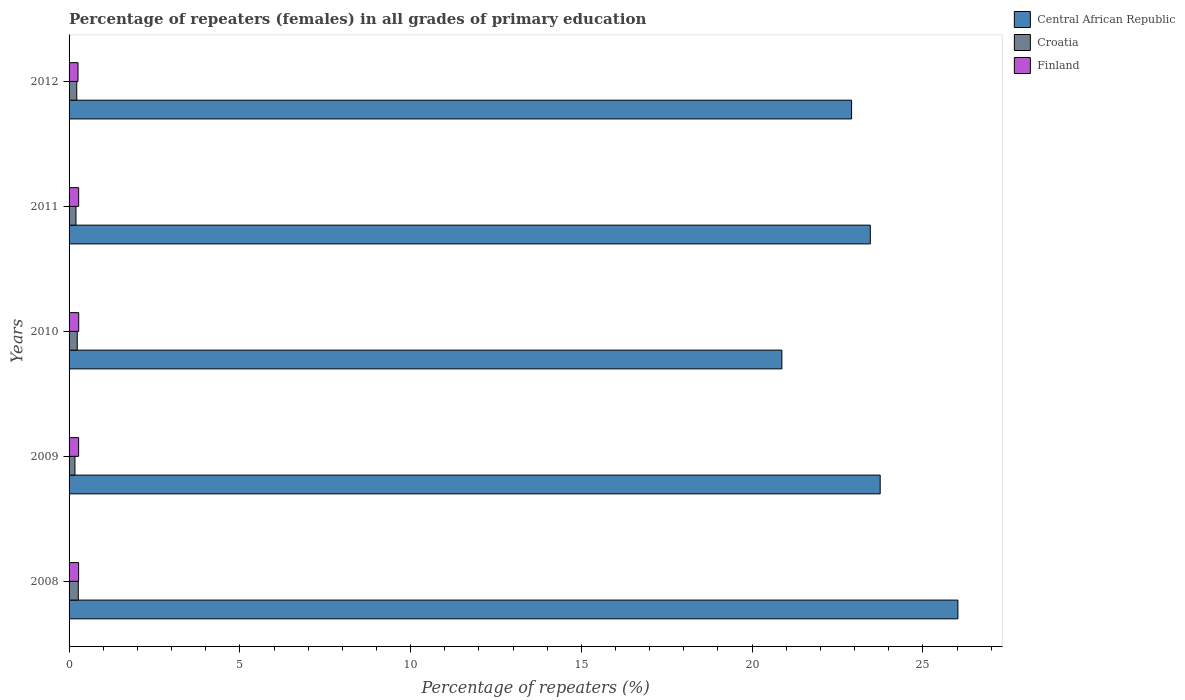How many groups of bars are there?
Offer a terse response. 5. Are the number of bars per tick equal to the number of legend labels?
Provide a short and direct response. Yes. How many bars are there on the 2nd tick from the top?
Keep it short and to the point. 3. In how many cases, is the number of bars for a given year not equal to the number of legend labels?
Provide a short and direct response. 0. What is the percentage of repeaters (females) in Croatia in 2012?
Offer a very short reply. 0.22. Across all years, what is the maximum percentage of repeaters (females) in Finland?
Keep it short and to the point. 0.28. Across all years, what is the minimum percentage of repeaters (females) in Central African Republic?
Make the answer very short. 20.87. In which year was the percentage of repeaters (females) in Central African Republic maximum?
Ensure brevity in your answer.  2008. In which year was the percentage of repeaters (females) in Croatia minimum?
Ensure brevity in your answer.  2009. What is the total percentage of repeaters (females) in Croatia in the graph?
Your answer should be compact. 1.11. What is the difference between the percentage of repeaters (females) in Finland in 2009 and that in 2010?
Ensure brevity in your answer.  -0. What is the difference between the percentage of repeaters (females) in Finland in 2009 and the percentage of repeaters (females) in Central African Republic in 2008?
Your response must be concise. -25.74. What is the average percentage of repeaters (females) in Central African Republic per year?
Make the answer very short. 23.4. In the year 2008, what is the difference between the percentage of repeaters (females) in Central African Republic and percentage of repeaters (females) in Croatia?
Make the answer very short. 25.75. What is the ratio of the percentage of repeaters (females) in Croatia in 2009 to that in 2011?
Make the answer very short. 0.85. Is the difference between the percentage of repeaters (females) in Central African Republic in 2009 and 2011 greater than the difference between the percentage of repeaters (females) in Croatia in 2009 and 2011?
Provide a succinct answer. Yes. What is the difference between the highest and the second highest percentage of repeaters (females) in Central African Republic?
Ensure brevity in your answer.  2.28. What is the difference between the highest and the lowest percentage of repeaters (females) in Croatia?
Provide a succinct answer. 0.1. In how many years, is the percentage of repeaters (females) in Croatia greater than the average percentage of repeaters (females) in Croatia taken over all years?
Keep it short and to the point. 3. What does the 2nd bar from the top in 2012 represents?
Keep it short and to the point. Croatia. What does the 2nd bar from the bottom in 2012 represents?
Your response must be concise. Croatia. Is it the case that in every year, the sum of the percentage of repeaters (females) in Finland and percentage of repeaters (females) in Croatia is greater than the percentage of repeaters (females) in Central African Republic?
Offer a terse response. No. Are all the bars in the graph horizontal?
Offer a terse response. Yes. How many years are there in the graph?
Ensure brevity in your answer.  5. What is the difference between two consecutive major ticks on the X-axis?
Keep it short and to the point. 5. Does the graph contain any zero values?
Offer a very short reply. No. Does the graph contain grids?
Your answer should be compact. No. What is the title of the graph?
Give a very brief answer. Percentage of repeaters (females) in all grades of primary education. Does "Mauritius" appear as one of the legend labels in the graph?
Offer a very short reply. No. What is the label or title of the X-axis?
Give a very brief answer. Percentage of repeaters (%). What is the label or title of the Y-axis?
Your answer should be very brief. Years. What is the Percentage of repeaters (%) of Central African Republic in 2008?
Provide a succinct answer. 26.02. What is the Percentage of repeaters (%) of Croatia in 2008?
Your response must be concise. 0.27. What is the Percentage of repeaters (%) in Finland in 2008?
Ensure brevity in your answer.  0.28. What is the Percentage of repeaters (%) in Central African Republic in 2009?
Your answer should be compact. 23.75. What is the Percentage of repeaters (%) of Croatia in 2009?
Keep it short and to the point. 0.17. What is the Percentage of repeaters (%) in Finland in 2009?
Your response must be concise. 0.28. What is the Percentage of repeaters (%) of Central African Republic in 2010?
Your answer should be very brief. 20.87. What is the Percentage of repeaters (%) in Croatia in 2010?
Offer a terse response. 0.24. What is the Percentage of repeaters (%) of Finland in 2010?
Your answer should be very brief. 0.28. What is the Percentage of repeaters (%) in Central African Republic in 2011?
Give a very brief answer. 23.46. What is the Percentage of repeaters (%) of Croatia in 2011?
Make the answer very short. 0.2. What is the Percentage of repeaters (%) of Finland in 2011?
Give a very brief answer. 0.28. What is the Percentage of repeaters (%) of Central African Republic in 2012?
Provide a short and direct response. 22.91. What is the Percentage of repeaters (%) of Croatia in 2012?
Your answer should be compact. 0.22. What is the Percentage of repeaters (%) of Finland in 2012?
Offer a very short reply. 0.26. Across all years, what is the maximum Percentage of repeaters (%) in Central African Republic?
Your response must be concise. 26.02. Across all years, what is the maximum Percentage of repeaters (%) of Croatia?
Give a very brief answer. 0.27. Across all years, what is the maximum Percentage of repeaters (%) in Finland?
Your response must be concise. 0.28. Across all years, what is the minimum Percentage of repeaters (%) of Central African Republic?
Provide a succinct answer. 20.87. Across all years, what is the minimum Percentage of repeaters (%) of Croatia?
Your answer should be very brief. 0.17. Across all years, what is the minimum Percentage of repeaters (%) in Finland?
Offer a very short reply. 0.26. What is the total Percentage of repeaters (%) in Central African Republic in the graph?
Your answer should be very brief. 117.02. What is the total Percentage of repeaters (%) of Croatia in the graph?
Your answer should be very brief. 1.11. What is the total Percentage of repeaters (%) of Finland in the graph?
Your answer should be very brief. 1.38. What is the difference between the Percentage of repeaters (%) of Central African Republic in 2008 and that in 2009?
Your response must be concise. 2.28. What is the difference between the Percentage of repeaters (%) in Croatia in 2008 and that in 2009?
Make the answer very short. 0.1. What is the difference between the Percentage of repeaters (%) of Finland in 2008 and that in 2009?
Your response must be concise. -0. What is the difference between the Percentage of repeaters (%) of Central African Republic in 2008 and that in 2010?
Offer a very short reply. 5.15. What is the difference between the Percentage of repeaters (%) of Croatia in 2008 and that in 2010?
Ensure brevity in your answer.  0.03. What is the difference between the Percentage of repeaters (%) of Finland in 2008 and that in 2010?
Give a very brief answer. -0. What is the difference between the Percentage of repeaters (%) in Central African Republic in 2008 and that in 2011?
Your answer should be compact. 2.56. What is the difference between the Percentage of repeaters (%) of Croatia in 2008 and that in 2011?
Offer a terse response. 0.07. What is the difference between the Percentage of repeaters (%) in Finland in 2008 and that in 2011?
Your answer should be compact. -0. What is the difference between the Percentage of repeaters (%) in Central African Republic in 2008 and that in 2012?
Give a very brief answer. 3.11. What is the difference between the Percentage of repeaters (%) of Croatia in 2008 and that in 2012?
Give a very brief answer. 0.05. What is the difference between the Percentage of repeaters (%) of Finland in 2008 and that in 2012?
Your response must be concise. 0.02. What is the difference between the Percentage of repeaters (%) of Central African Republic in 2009 and that in 2010?
Give a very brief answer. 2.88. What is the difference between the Percentage of repeaters (%) in Croatia in 2009 and that in 2010?
Your response must be concise. -0.07. What is the difference between the Percentage of repeaters (%) in Finland in 2009 and that in 2010?
Your response must be concise. -0. What is the difference between the Percentage of repeaters (%) in Central African Republic in 2009 and that in 2011?
Provide a short and direct response. 0.29. What is the difference between the Percentage of repeaters (%) of Croatia in 2009 and that in 2011?
Your answer should be very brief. -0.03. What is the difference between the Percentage of repeaters (%) of Finland in 2009 and that in 2011?
Your answer should be very brief. -0. What is the difference between the Percentage of repeaters (%) in Central African Republic in 2009 and that in 2012?
Ensure brevity in your answer.  0.84. What is the difference between the Percentage of repeaters (%) in Croatia in 2009 and that in 2012?
Give a very brief answer. -0.05. What is the difference between the Percentage of repeaters (%) in Finland in 2009 and that in 2012?
Give a very brief answer. 0.02. What is the difference between the Percentage of repeaters (%) of Central African Republic in 2010 and that in 2011?
Provide a succinct answer. -2.59. What is the difference between the Percentage of repeaters (%) of Croatia in 2010 and that in 2011?
Offer a very short reply. 0.04. What is the difference between the Percentage of repeaters (%) of Finland in 2010 and that in 2011?
Ensure brevity in your answer.  0. What is the difference between the Percentage of repeaters (%) of Central African Republic in 2010 and that in 2012?
Provide a short and direct response. -2.04. What is the difference between the Percentage of repeaters (%) of Croatia in 2010 and that in 2012?
Make the answer very short. 0.01. What is the difference between the Percentage of repeaters (%) of Finland in 2010 and that in 2012?
Provide a succinct answer. 0.02. What is the difference between the Percentage of repeaters (%) in Central African Republic in 2011 and that in 2012?
Make the answer very short. 0.55. What is the difference between the Percentage of repeaters (%) of Croatia in 2011 and that in 2012?
Offer a terse response. -0.02. What is the difference between the Percentage of repeaters (%) of Finland in 2011 and that in 2012?
Your answer should be very brief. 0.02. What is the difference between the Percentage of repeaters (%) of Central African Republic in 2008 and the Percentage of repeaters (%) of Croatia in 2009?
Offer a terse response. 25.85. What is the difference between the Percentage of repeaters (%) of Central African Republic in 2008 and the Percentage of repeaters (%) of Finland in 2009?
Your answer should be compact. 25.74. What is the difference between the Percentage of repeaters (%) of Croatia in 2008 and the Percentage of repeaters (%) of Finland in 2009?
Your response must be concise. -0.01. What is the difference between the Percentage of repeaters (%) in Central African Republic in 2008 and the Percentage of repeaters (%) in Croatia in 2010?
Ensure brevity in your answer.  25.79. What is the difference between the Percentage of repeaters (%) in Central African Republic in 2008 and the Percentage of repeaters (%) in Finland in 2010?
Your answer should be compact. 25.74. What is the difference between the Percentage of repeaters (%) of Croatia in 2008 and the Percentage of repeaters (%) of Finland in 2010?
Your response must be concise. -0.01. What is the difference between the Percentage of repeaters (%) in Central African Republic in 2008 and the Percentage of repeaters (%) in Croatia in 2011?
Your response must be concise. 25.82. What is the difference between the Percentage of repeaters (%) in Central African Republic in 2008 and the Percentage of repeaters (%) in Finland in 2011?
Offer a very short reply. 25.74. What is the difference between the Percentage of repeaters (%) of Croatia in 2008 and the Percentage of repeaters (%) of Finland in 2011?
Give a very brief answer. -0.01. What is the difference between the Percentage of repeaters (%) in Central African Republic in 2008 and the Percentage of repeaters (%) in Croatia in 2012?
Ensure brevity in your answer.  25.8. What is the difference between the Percentage of repeaters (%) in Central African Republic in 2008 and the Percentage of repeaters (%) in Finland in 2012?
Offer a very short reply. 25.76. What is the difference between the Percentage of repeaters (%) in Croatia in 2008 and the Percentage of repeaters (%) in Finland in 2012?
Provide a short and direct response. 0.01. What is the difference between the Percentage of repeaters (%) in Central African Republic in 2009 and the Percentage of repeaters (%) in Croatia in 2010?
Provide a short and direct response. 23.51. What is the difference between the Percentage of repeaters (%) in Central African Republic in 2009 and the Percentage of repeaters (%) in Finland in 2010?
Your response must be concise. 23.47. What is the difference between the Percentage of repeaters (%) of Croatia in 2009 and the Percentage of repeaters (%) of Finland in 2010?
Give a very brief answer. -0.11. What is the difference between the Percentage of repeaters (%) in Central African Republic in 2009 and the Percentage of repeaters (%) in Croatia in 2011?
Offer a terse response. 23.55. What is the difference between the Percentage of repeaters (%) in Central African Republic in 2009 and the Percentage of repeaters (%) in Finland in 2011?
Provide a short and direct response. 23.47. What is the difference between the Percentage of repeaters (%) in Croatia in 2009 and the Percentage of repeaters (%) in Finland in 2011?
Your response must be concise. -0.11. What is the difference between the Percentage of repeaters (%) in Central African Republic in 2009 and the Percentage of repeaters (%) in Croatia in 2012?
Keep it short and to the point. 23.52. What is the difference between the Percentage of repeaters (%) of Central African Republic in 2009 and the Percentage of repeaters (%) of Finland in 2012?
Your answer should be very brief. 23.49. What is the difference between the Percentage of repeaters (%) of Croatia in 2009 and the Percentage of repeaters (%) of Finland in 2012?
Provide a short and direct response. -0.09. What is the difference between the Percentage of repeaters (%) in Central African Republic in 2010 and the Percentage of repeaters (%) in Croatia in 2011?
Your response must be concise. 20.67. What is the difference between the Percentage of repeaters (%) of Central African Republic in 2010 and the Percentage of repeaters (%) of Finland in 2011?
Keep it short and to the point. 20.59. What is the difference between the Percentage of repeaters (%) in Croatia in 2010 and the Percentage of repeaters (%) in Finland in 2011?
Your answer should be compact. -0.04. What is the difference between the Percentage of repeaters (%) of Central African Republic in 2010 and the Percentage of repeaters (%) of Croatia in 2012?
Your answer should be compact. 20.65. What is the difference between the Percentage of repeaters (%) of Central African Republic in 2010 and the Percentage of repeaters (%) of Finland in 2012?
Your answer should be very brief. 20.61. What is the difference between the Percentage of repeaters (%) in Croatia in 2010 and the Percentage of repeaters (%) in Finland in 2012?
Offer a terse response. -0.02. What is the difference between the Percentage of repeaters (%) in Central African Republic in 2011 and the Percentage of repeaters (%) in Croatia in 2012?
Make the answer very short. 23.23. What is the difference between the Percentage of repeaters (%) in Central African Republic in 2011 and the Percentage of repeaters (%) in Finland in 2012?
Ensure brevity in your answer.  23.2. What is the difference between the Percentage of repeaters (%) in Croatia in 2011 and the Percentage of repeaters (%) in Finland in 2012?
Offer a terse response. -0.06. What is the average Percentage of repeaters (%) of Central African Republic per year?
Provide a succinct answer. 23.4. What is the average Percentage of repeaters (%) in Croatia per year?
Provide a short and direct response. 0.22. What is the average Percentage of repeaters (%) of Finland per year?
Your answer should be compact. 0.28. In the year 2008, what is the difference between the Percentage of repeaters (%) of Central African Republic and Percentage of repeaters (%) of Croatia?
Offer a terse response. 25.75. In the year 2008, what is the difference between the Percentage of repeaters (%) in Central African Republic and Percentage of repeaters (%) in Finland?
Make the answer very short. 25.75. In the year 2008, what is the difference between the Percentage of repeaters (%) in Croatia and Percentage of repeaters (%) in Finland?
Make the answer very short. -0.01. In the year 2009, what is the difference between the Percentage of repeaters (%) in Central African Republic and Percentage of repeaters (%) in Croatia?
Ensure brevity in your answer.  23.58. In the year 2009, what is the difference between the Percentage of repeaters (%) of Central African Republic and Percentage of repeaters (%) of Finland?
Your answer should be compact. 23.47. In the year 2009, what is the difference between the Percentage of repeaters (%) of Croatia and Percentage of repeaters (%) of Finland?
Your response must be concise. -0.11. In the year 2010, what is the difference between the Percentage of repeaters (%) of Central African Republic and Percentage of repeaters (%) of Croatia?
Your response must be concise. 20.63. In the year 2010, what is the difference between the Percentage of repeaters (%) of Central African Republic and Percentage of repeaters (%) of Finland?
Give a very brief answer. 20.59. In the year 2010, what is the difference between the Percentage of repeaters (%) in Croatia and Percentage of repeaters (%) in Finland?
Offer a terse response. -0.04. In the year 2011, what is the difference between the Percentage of repeaters (%) of Central African Republic and Percentage of repeaters (%) of Croatia?
Provide a short and direct response. 23.26. In the year 2011, what is the difference between the Percentage of repeaters (%) in Central African Republic and Percentage of repeaters (%) in Finland?
Offer a terse response. 23.18. In the year 2011, what is the difference between the Percentage of repeaters (%) of Croatia and Percentage of repeaters (%) of Finland?
Your answer should be compact. -0.08. In the year 2012, what is the difference between the Percentage of repeaters (%) in Central African Republic and Percentage of repeaters (%) in Croatia?
Your answer should be compact. 22.69. In the year 2012, what is the difference between the Percentage of repeaters (%) in Central African Republic and Percentage of repeaters (%) in Finland?
Your response must be concise. 22.65. In the year 2012, what is the difference between the Percentage of repeaters (%) in Croatia and Percentage of repeaters (%) in Finland?
Your answer should be very brief. -0.04. What is the ratio of the Percentage of repeaters (%) of Central African Republic in 2008 to that in 2009?
Provide a short and direct response. 1.1. What is the ratio of the Percentage of repeaters (%) of Croatia in 2008 to that in 2009?
Ensure brevity in your answer.  1.57. What is the ratio of the Percentage of repeaters (%) in Finland in 2008 to that in 2009?
Give a very brief answer. 1. What is the ratio of the Percentage of repeaters (%) of Central African Republic in 2008 to that in 2010?
Your answer should be very brief. 1.25. What is the ratio of the Percentage of repeaters (%) of Croatia in 2008 to that in 2010?
Offer a terse response. 1.13. What is the ratio of the Percentage of repeaters (%) of Central African Republic in 2008 to that in 2011?
Offer a very short reply. 1.11. What is the ratio of the Percentage of repeaters (%) of Croatia in 2008 to that in 2011?
Offer a terse response. 1.34. What is the ratio of the Percentage of repeaters (%) in Central African Republic in 2008 to that in 2012?
Provide a short and direct response. 1.14. What is the ratio of the Percentage of repeaters (%) of Croatia in 2008 to that in 2012?
Make the answer very short. 1.2. What is the ratio of the Percentage of repeaters (%) in Finland in 2008 to that in 2012?
Provide a succinct answer. 1.07. What is the ratio of the Percentage of repeaters (%) in Central African Republic in 2009 to that in 2010?
Your answer should be compact. 1.14. What is the ratio of the Percentage of repeaters (%) of Croatia in 2009 to that in 2010?
Offer a very short reply. 0.72. What is the ratio of the Percentage of repeaters (%) of Central African Republic in 2009 to that in 2011?
Give a very brief answer. 1.01. What is the ratio of the Percentage of repeaters (%) in Croatia in 2009 to that in 2011?
Give a very brief answer. 0.85. What is the ratio of the Percentage of repeaters (%) of Central African Republic in 2009 to that in 2012?
Your answer should be compact. 1.04. What is the ratio of the Percentage of repeaters (%) in Croatia in 2009 to that in 2012?
Provide a succinct answer. 0.77. What is the ratio of the Percentage of repeaters (%) in Finland in 2009 to that in 2012?
Give a very brief answer. 1.07. What is the ratio of the Percentage of repeaters (%) of Central African Republic in 2010 to that in 2011?
Your answer should be very brief. 0.89. What is the ratio of the Percentage of repeaters (%) of Croatia in 2010 to that in 2011?
Provide a succinct answer. 1.19. What is the ratio of the Percentage of repeaters (%) in Finland in 2010 to that in 2011?
Offer a very short reply. 1.01. What is the ratio of the Percentage of repeaters (%) of Central African Republic in 2010 to that in 2012?
Provide a short and direct response. 0.91. What is the ratio of the Percentage of repeaters (%) in Croatia in 2010 to that in 2012?
Provide a succinct answer. 1.06. What is the ratio of the Percentage of repeaters (%) of Finland in 2010 to that in 2012?
Give a very brief answer. 1.08. What is the ratio of the Percentage of repeaters (%) of Central African Republic in 2011 to that in 2012?
Your answer should be very brief. 1.02. What is the ratio of the Percentage of repeaters (%) in Croatia in 2011 to that in 2012?
Your response must be concise. 0.9. What is the ratio of the Percentage of repeaters (%) of Finland in 2011 to that in 2012?
Your answer should be compact. 1.07. What is the difference between the highest and the second highest Percentage of repeaters (%) in Central African Republic?
Your answer should be very brief. 2.28. What is the difference between the highest and the second highest Percentage of repeaters (%) of Croatia?
Offer a very short reply. 0.03. What is the difference between the highest and the second highest Percentage of repeaters (%) of Finland?
Give a very brief answer. 0. What is the difference between the highest and the lowest Percentage of repeaters (%) of Central African Republic?
Give a very brief answer. 5.15. What is the difference between the highest and the lowest Percentage of repeaters (%) in Croatia?
Provide a short and direct response. 0.1. What is the difference between the highest and the lowest Percentage of repeaters (%) in Finland?
Offer a very short reply. 0.02. 